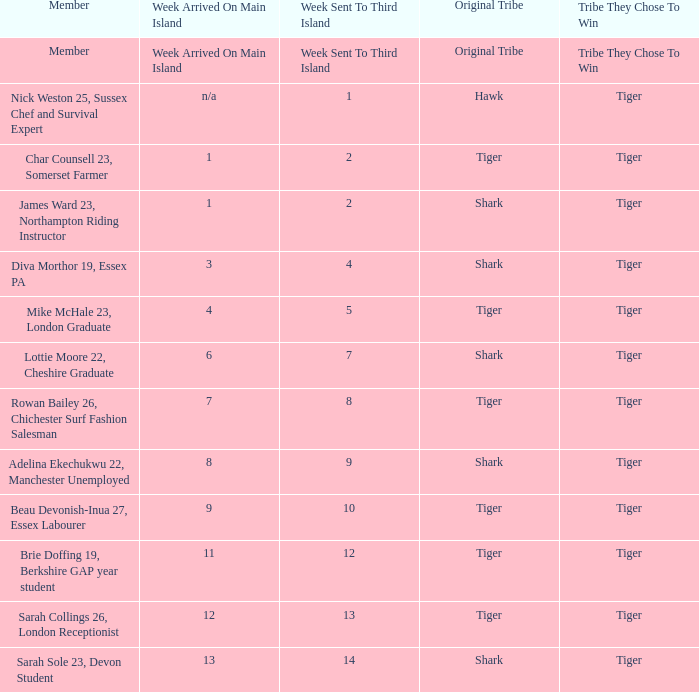What week did the member who's original tribe was shark and who was sent to the third island on week 14 arrive on the main island? 13.0. 